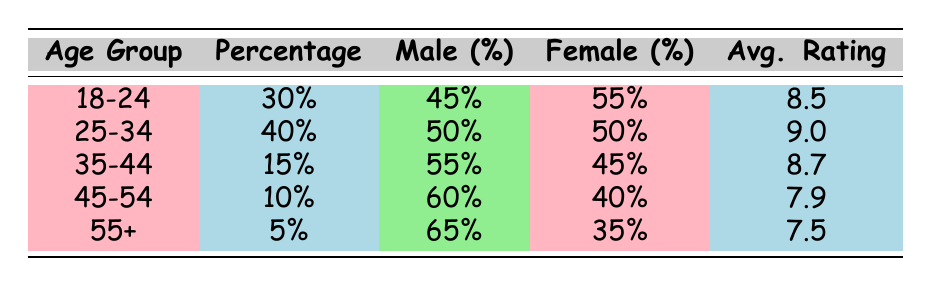What percentage of viewers are aged 25-34? The table states that the percentage of viewers within the age group of 25-34 is 40%.
Answer: 40% Which age group has the highest average rating? Looking at the average ratings column, the age group 25-34 has the highest rating at 9.0.
Answer: 25-34 Is the percentage of female viewers in the 18-24 age group higher than in the 35-44 age group? The female percentage in the 18-24 age group is 55%, while in the 35-44 age group it is 45%. Since 55% is greater than 45%, the statement is true.
Answer: Yes What is the average rating of viewers aged 45-54? According to the table, the average rating for the 45-54 age group is 7.9.
Answer: 7.9 What is the total percentage of viewers in the age groups 18-24 and 35-44 combined? Adding the percentages of the 18-24 (30%) and 35-44 (15%) age groups gives a total of (30 + 15) = 45%.
Answer: 45% Does the male percentage in the 55+ age group exceed 60%? The male percentage in the 55+ age group is 65%, which is greater than 60%. Therefore, the answer is true.
Answer: Yes What is the difference in average ratings between the 25-34 and 45-54 age groups? The average rating for the 25-34 age group is 9.0, and for the 45-54 age group, it is 7.9. The difference is (9.0 - 7.9) = 1.1.
Answer: 1.1 What percentage of viewers are aged 55 or older? The only age group that is 55 or older is the 55+ group, which accounts for 5%.
Answer: 5% Are there more male viewers in the 35-44 age group than in the 45-54 age group? In the 35-44 age group, the male percentage is 55%, and in the 45-54 age group, it is 60%. Therefore, there are fewer male viewers in the 35-44 age group.
Answer: No 